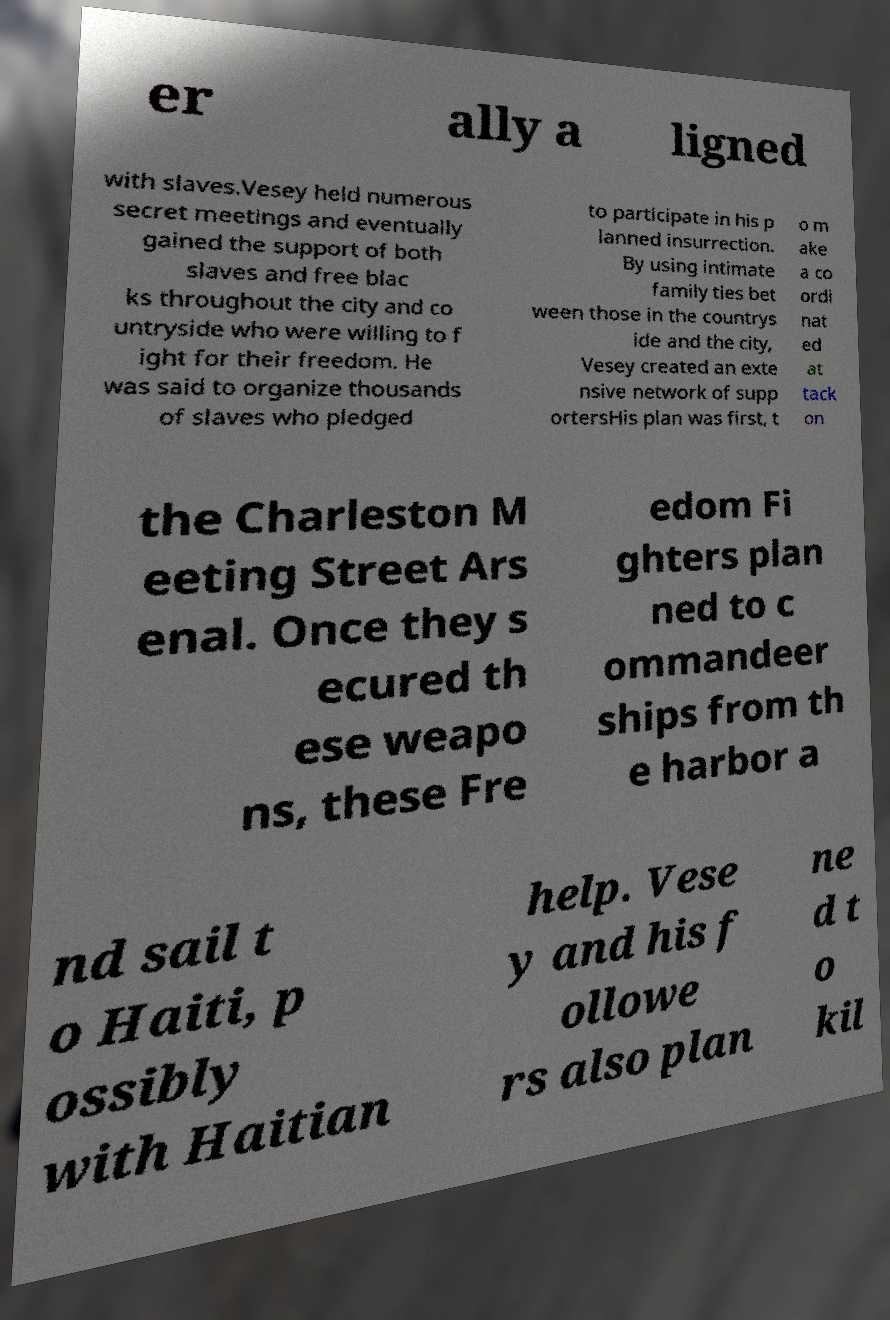Please read and relay the text visible in this image. What does it say? er ally a ligned with slaves.Vesey held numerous secret meetings and eventually gained the support of both slaves and free blac ks throughout the city and co untryside who were willing to f ight for their freedom. He was said to organize thousands of slaves who pledged to participate in his p lanned insurrection. By using intimate family ties bet ween those in the countrys ide and the city, Vesey created an exte nsive network of supp ortersHis plan was first, t o m ake a co ordi nat ed at tack on the Charleston M eeting Street Ars enal. Once they s ecured th ese weapo ns, these Fre edom Fi ghters plan ned to c ommandeer ships from th e harbor a nd sail t o Haiti, p ossibly with Haitian help. Vese y and his f ollowe rs also plan ne d t o kil 